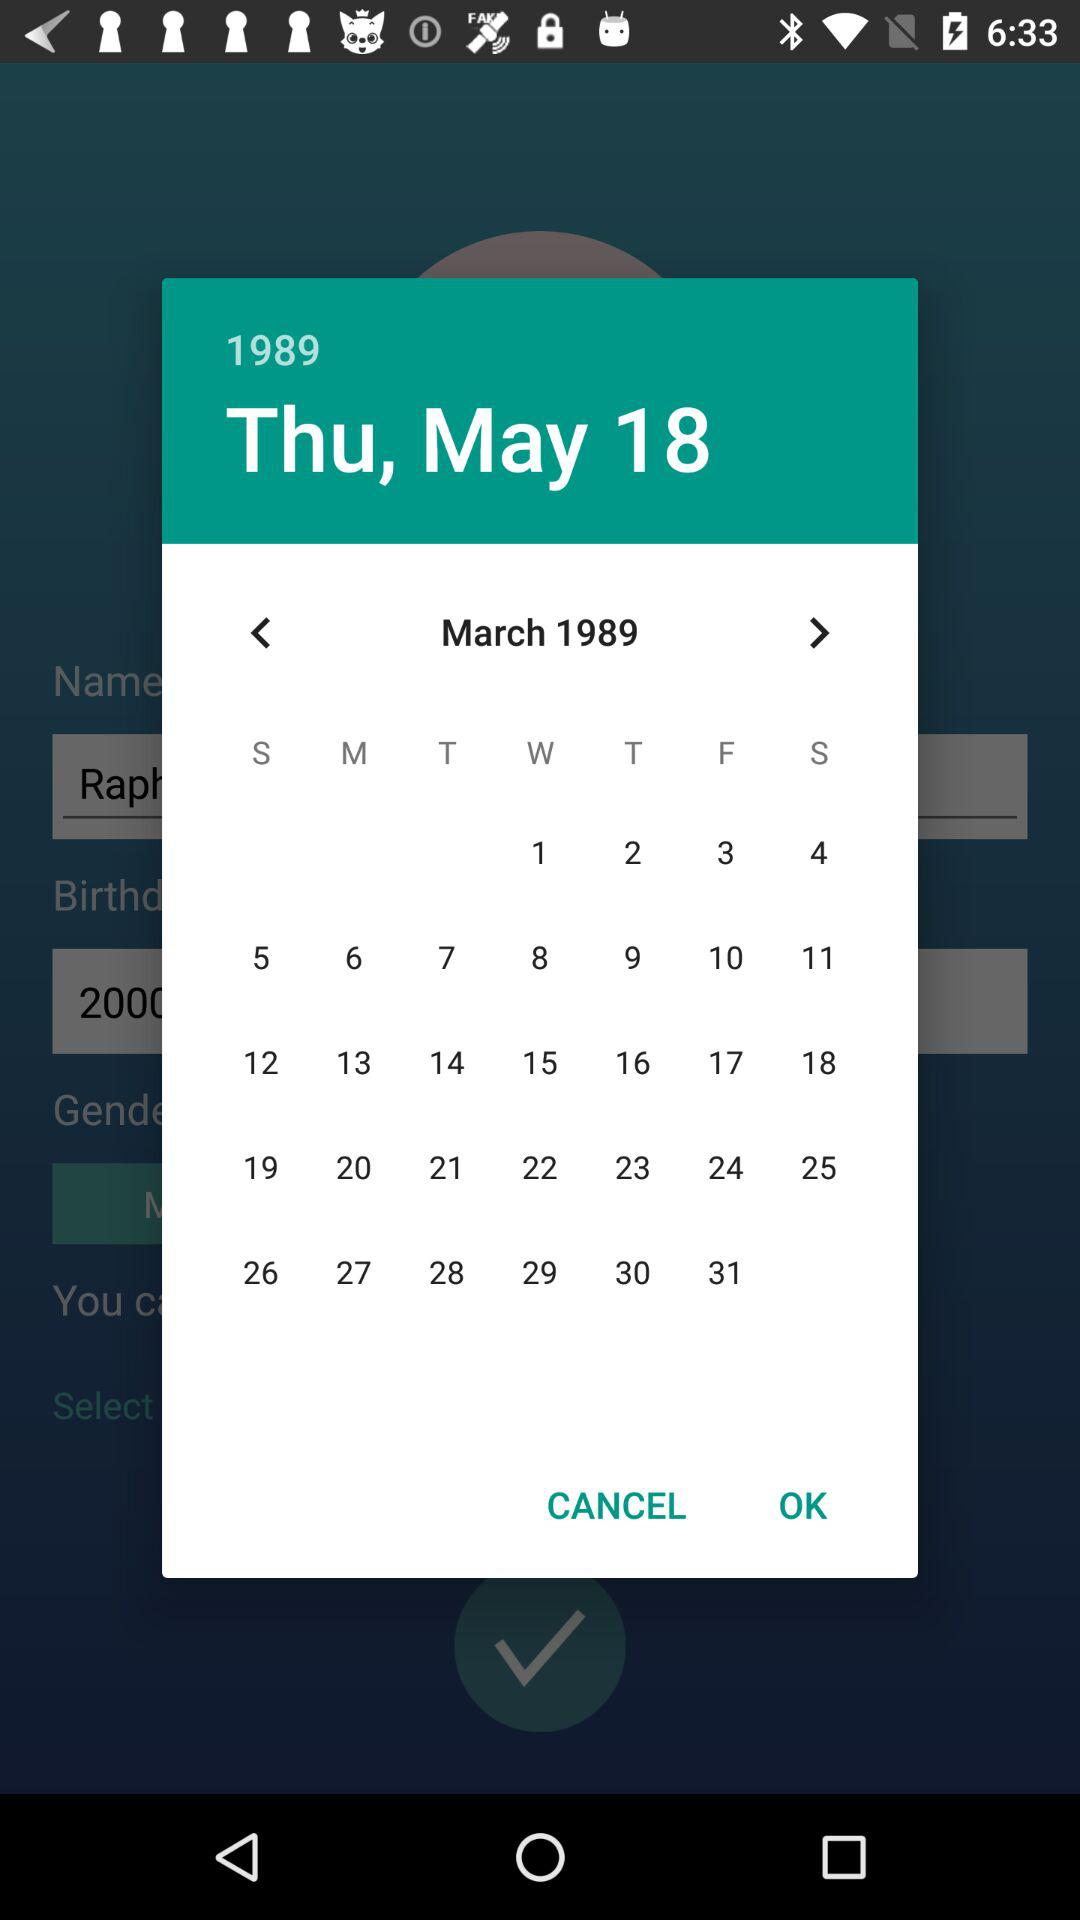What is the selected date? The selected date is Thursday, 18 May, 1989. 